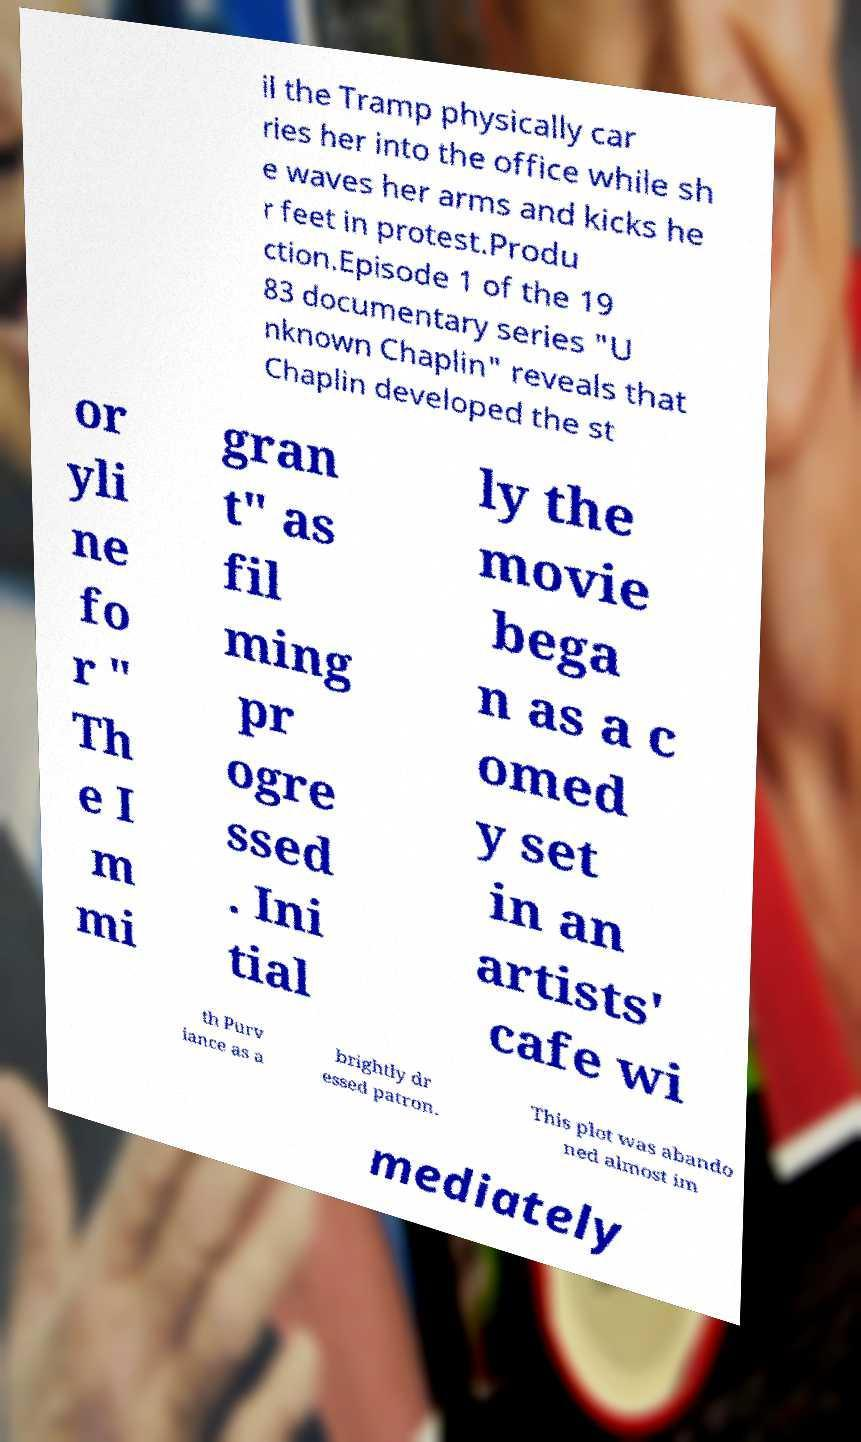Please identify and transcribe the text found in this image. il the Tramp physically car ries her into the office while sh e waves her arms and kicks he r feet in protest.Produ ction.Episode 1 of the 19 83 documentary series "U nknown Chaplin" reveals that Chaplin developed the st or yli ne fo r " Th e I m mi gran t" as fil ming pr ogre ssed . Ini tial ly the movie bega n as a c omed y set in an artists' cafe wi th Purv iance as a brightly dr essed patron. This plot was abando ned almost im mediately 